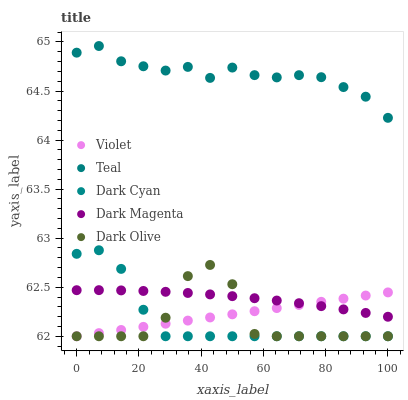Does Dark Olive have the minimum area under the curve?
Answer yes or no. Yes. Does Teal have the maximum area under the curve?
Answer yes or no. Yes. Does Dark Magenta have the minimum area under the curve?
Answer yes or no. No. Does Dark Magenta have the maximum area under the curve?
Answer yes or no. No. Is Violet the smoothest?
Answer yes or no. Yes. Is Dark Olive the roughest?
Answer yes or no. Yes. Is Dark Magenta the smoothest?
Answer yes or no. No. Is Dark Magenta the roughest?
Answer yes or no. No. Does Dark Cyan have the lowest value?
Answer yes or no. Yes. Does Dark Magenta have the lowest value?
Answer yes or no. No. Does Teal have the highest value?
Answer yes or no. Yes. Does Dark Olive have the highest value?
Answer yes or no. No. Is Violet less than Teal?
Answer yes or no. Yes. Is Teal greater than Dark Magenta?
Answer yes or no. Yes. Does Dark Magenta intersect Dark Cyan?
Answer yes or no. Yes. Is Dark Magenta less than Dark Cyan?
Answer yes or no. No. Is Dark Magenta greater than Dark Cyan?
Answer yes or no. No. Does Violet intersect Teal?
Answer yes or no. No. 